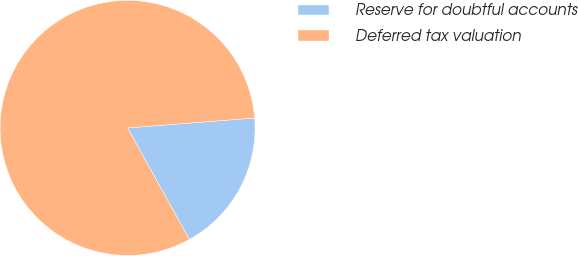Convert chart to OTSL. <chart><loc_0><loc_0><loc_500><loc_500><pie_chart><fcel>Reserve for doubtful accounts<fcel>Deferred tax valuation<nl><fcel>18.18%<fcel>81.82%<nl></chart> 